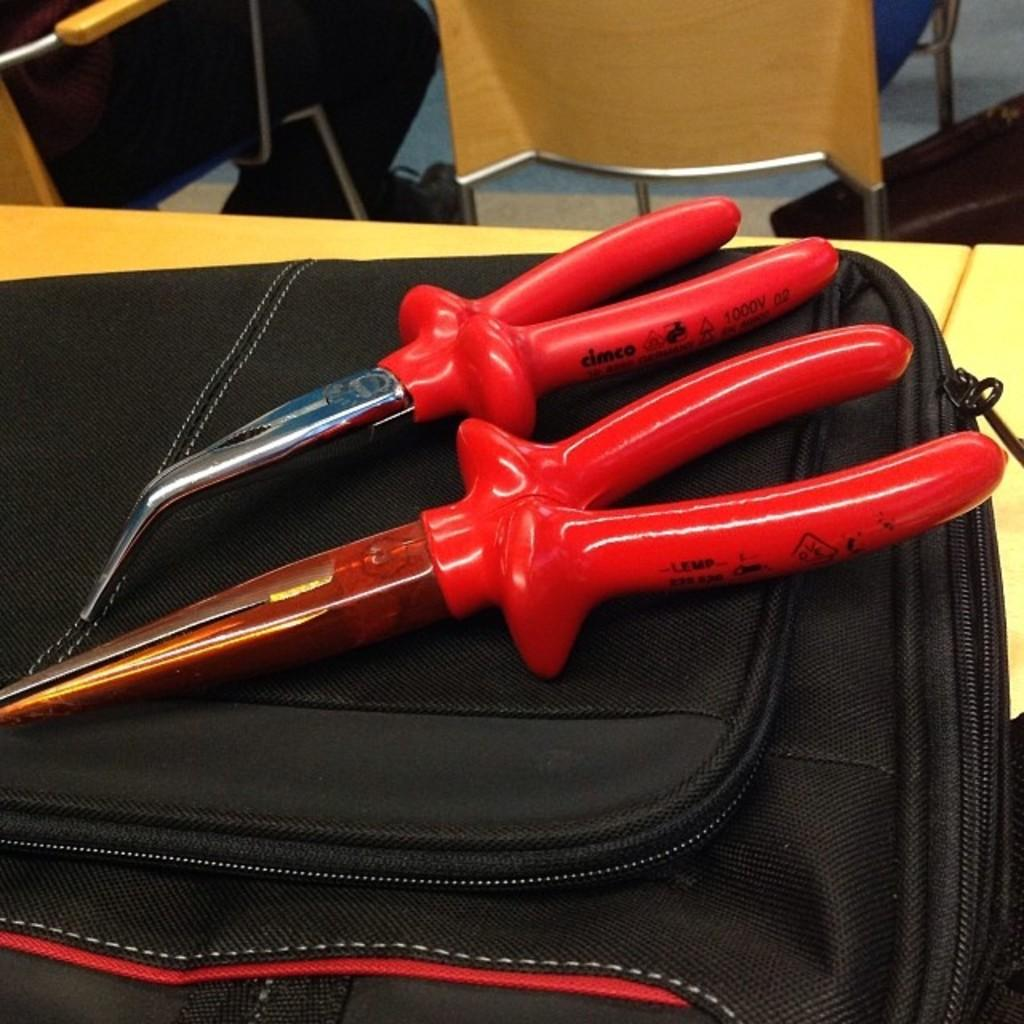What color are the two objects in the image? The two objects in the image are red. Where are the red objects placed? The red objects are placed on a black bag. What is the black bag resting on? The black bag is placed on a table. Can you describe any other objects visible in the background of the image? Unfortunately, the provided facts do not give any information about the objects in the background. What is the rate of pain experienced by the kettle in the image? There is no kettle present in the image, and therefore no pain can be experienced or measured. 